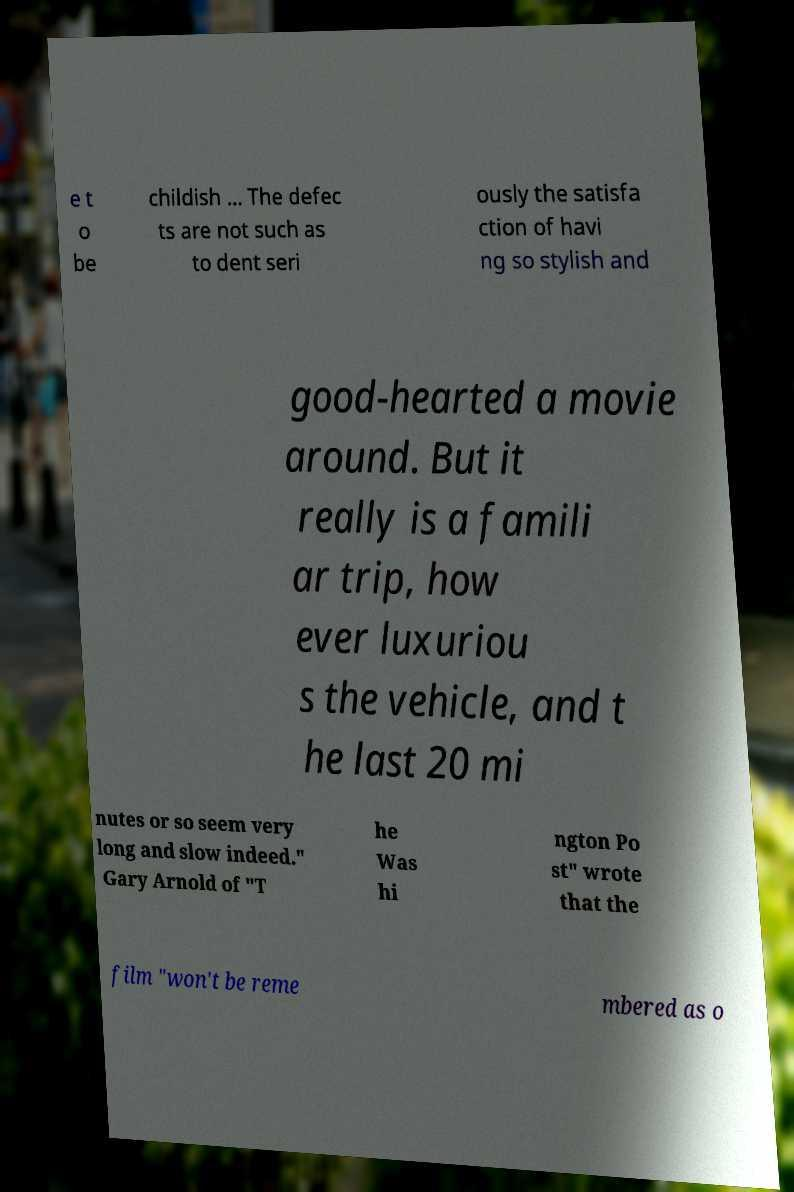Can you read and provide the text displayed in the image?This photo seems to have some interesting text. Can you extract and type it out for me? e t o be childish ... The defec ts are not such as to dent seri ously the satisfa ction of havi ng so stylish and good-hearted a movie around. But it really is a famili ar trip, how ever luxuriou s the vehicle, and t he last 20 mi nutes or so seem very long and slow indeed." Gary Arnold of "T he Was hi ngton Po st" wrote that the film "won't be reme mbered as o 